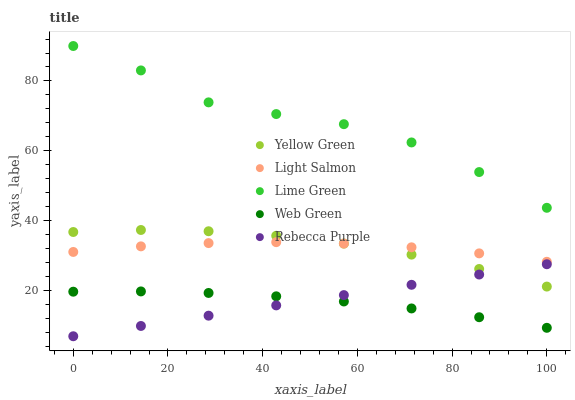Does Web Green have the minimum area under the curve?
Answer yes or no. Yes. Does Lime Green have the maximum area under the curve?
Answer yes or no. Yes. Does Yellow Green have the minimum area under the curve?
Answer yes or no. No. Does Yellow Green have the maximum area under the curve?
Answer yes or no. No. Is Rebecca Purple the smoothest?
Answer yes or no. Yes. Is Lime Green the roughest?
Answer yes or no. Yes. Is Yellow Green the smoothest?
Answer yes or no. No. Is Yellow Green the roughest?
Answer yes or no. No. Does Rebecca Purple have the lowest value?
Answer yes or no. Yes. Does Yellow Green have the lowest value?
Answer yes or no. No. Does Lime Green have the highest value?
Answer yes or no. Yes. Does Yellow Green have the highest value?
Answer yes or no. No. Is Rebecca Purple less than Lime Green?
Answer yes or no. Yes. Is Light Salmon greater than Web Green?
Answer yes or no. Yes. Does Yellow Green intersect Rebecca Purple?
Answer yes or no. Yes. Is Yellow Green less than Rebecca Purple?
Answer yes or no. No. Is Yellow Green greater than Rebecca Purple?
Answer yes or no. No. Does Rebecca Purple intersect Lime Green?
Answer yes or no. No. 